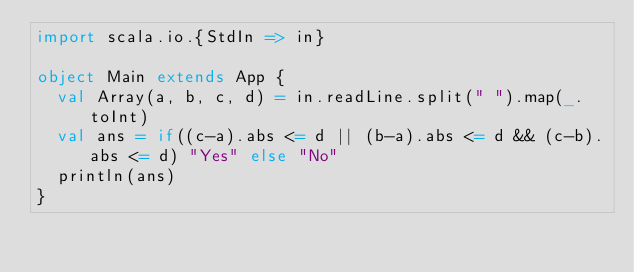<code> <loc_0><loc_0><loc_500><loc_500><_Scala_>import scala.io.{StdIn => in}

object Main extends App {
  val Array(a, b, c, d) = in.readLine.split(" ").map(_.toInt)
  val ans = if((c-a).abs <= d || (b-a).abs <= d && (c-b).abs <= d) "Yes" else "No"
  println(ans)
}</code> 